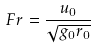<formula> <loc_0><loc_0><loc_500><loc_500>F r = \frac { u _ { 0 } } { \sqrt { g _ { 0 } r _ { 0 } } }</formula> 